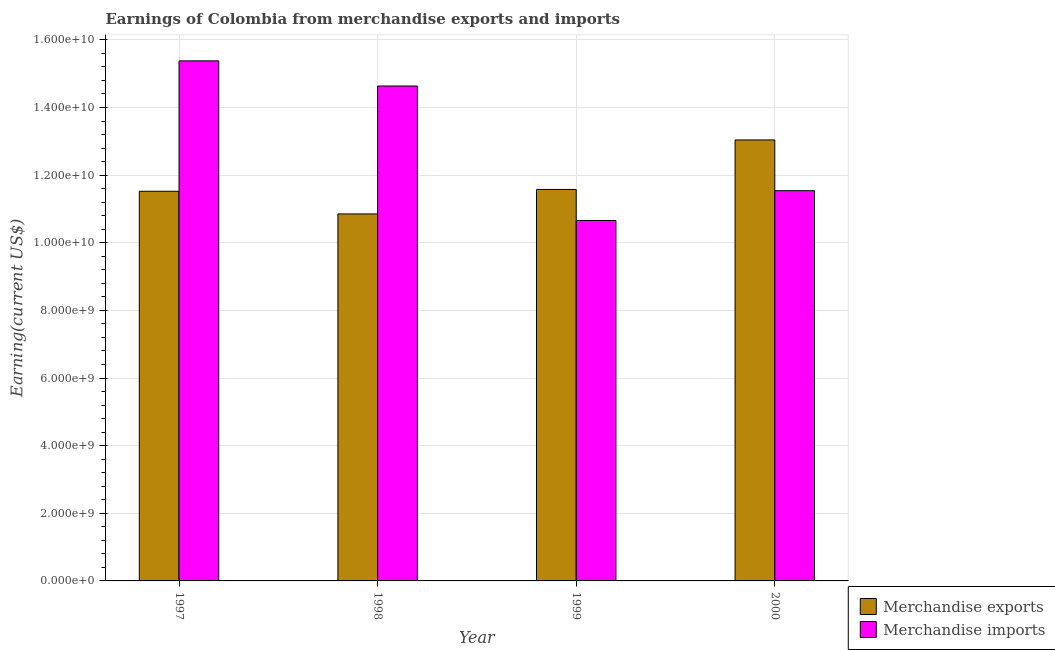Are the number of bars per tick equal to the number of legend labels?
Your response must be concise. Yes. What is the earnings from merchandise exports in 1998?
Ensure brevity in your answer.  1.09e+1. Across all years, what is the maximum earnings from merchandise exports?
Offer a terse response. 1.30e+1. Across all years, what is the minimum earnings from merchandise imports?
Provide a succinct answer. 1.07e+1. In which year was the earnings from merchandise exports maximum?
Offer a very short reply. 2000. In which year was the earnings from merchandise imports minimum?
Give a very brief answer. 1999. What is the total earnings from merchandise imports in the graph?
Your response must be concise. 5.22e+1. What is the difference between the earnings from merchandise imports in 1999 and that in 2000?
Your answer should be compact. -8.80e+08. What is the difference between the earnings from merchandise exports in 2000 and the earnings from merchandise imports in 1997?
Ensure brevity in your answer.  1.52e+09. What is the average earnings from merchandise exports per year?
Provide a succinct answer. 1.17e+1. In how many years, is the earnings from merchandise imports greater than 5200000000 US$?
Your answer should be very brief. 4. What is the ratio of the earnings from merchandise exports in 1997 to that in 1998?
Provide a short and direct response. 1.06. Is the earnings from merchandise imports in 1997 less than that in 1999?
Make the answer very short. No. What is the difference between the highest and the second highest earnings from merchandise exports?
Your answer should be very brief. 1.46e+09. What is the difference between the highest and the lowest earnings from merchandise exports?
Provide a short and direct response. 2.19e+09. What does the 2nd bar from the left in 1999 represents?
Offer a very short reply. Merchandise imports. Are all the bars in the graph horizontal?
Offer a very short reply. No. What is the difference between two consecutive major ticks on the Y-axis?
Provide a succinct answer. 2.00e+09. Are the values on the major ticks of Y-axis written in scientific E-notation?
Offer a terse response. Yes. Where does the legend appear in the graph?
Your answer should be compact. Bottom right. How are the legend labels stacked?
Provide a short and direct response. Vertical. What is the title of the graph?
Give a very brief answer. Earnings of Colombia from merchandise exports and imports. Does "Techinal cooperation" appear as one of the legend labels in the graph?
Your answer should be compact. No. What is the label or title of the Y-axis?
Your answer should be very brief. Earning(current US$). What is the Earning(current US$) in Merchandise exports in 1997?
Your response must be concise. 1.15e+1. What is the Earning(current US$) in Merchandise imports in 1997?
Offer a very short reply. 1.54e+1. What is the Earning(current US$) in Merchandise exports in 1998?
Offer a very short reply. 1.09e+1. What is the Earning(current US$) in Merchandise imports in 1998?
Your response must be concise. 1.46e+1. What is the Earning(current US$) of Merchandise exports in 1999?
Keep it short and to the point. 1.16e+1. What is the Earning(current US$) in Merchandise imports in 1999?
Give a very brief answer. 1.07e+1. What is the Earning(current US$) of Merchandise exports in 2000?
Offer a very short reply. 1.30e+1. What is the Earning(current US$) of Merchandise imports in 2000?
Keep it short and to the point. 1.15e+1. Across all years, what is the maximum Earning(current US$) in Merchandise exports?
Keep it short and to the point. 1.30e+1. Across all years, what is the maximum Earning(current US$) in Merchandise imports?
Offer a terse response. 1.54e+1. Across all years, what is the minimum Earning(current US$) of Merchandise exports?
Your answer should be compact. 1.09e+1. Across all years, what is the minimum Earning(current US$) of Merchandise imports?
Your answer should be compact. 1.07e+1. What is the total Earning(current US$) of Merchandise exports in the graph?
Ensure brevity in your answer.  4.70e+1. What is the total Earning(current US$) in Merchandise imports in the graph?
Ensure brevity in your answer.  5.22e+1. What is the difference between the Earning(current US$) in Merchandise exports in 1997 and that in 1998?
Offer a very short reply. 6.70e+08. What is the difference between the Earning(current US$) of Merchandise imports in 1997 and that in 1998?
Your answer should be compact. 7.43e+08. What is the difference between the Earning(current US$) in Merchandise exports in 1997 and that in 1999?
Offer a very short reply. -5.40e+07. What is the difference between the Earning(current US$) in Merchandise imports in 1997 and that in 1999?
Provide a short and direct response. 4.72e+09. What is the difference between the Earning(current US$) in Merchandise exports in 1997 and that in 2000?
Provide a short and direct response. -1.52e+09. What is the difference between the Earning(current US$) of Merchandise imports in 1997 and that in 2000?
Provide a short and direct response. 3.84e+09. What is the difference between the Earning(current US$) of Merchandise exports in 1998 and that in 1999?
Provide a short and direct response. -7.24e+08. What is the difference between the Earning(current US$) in Merchandise imports in 1998 and that in 1999?
Give a very brief answer. 3.98e+09. What is the difference between the Earning(current US$) in Merchandise exports in 1998 and that in 2000?
Your answer should be very brief. -2.19e+09. What is the difference between the Earning(current US$) of Merchandise imports in 1998 and that in 2000?
Make the answer very short. 3.10e+09. What is the difference between the Earning(current US$) in Merchandise exports in 1999 and that in 2000?
Your answer should be very brief. -1.46e+09. What is the difference between the Earning(current US$) in Merchandise imports in 1999 and that in 2000?
Offer a very short reply. -8.80e+08. What is the difference between the Earning(current US$) of Merchandise exports in 1997 and the Earning(current US$) of Merchandise imports in 1998?
Ensure brevity in your answer.  -3.11e+09. What is the difference between the Earning(current US$) of Merchandise exports in 1997 and the Earning(current US$) of Merchandise imports in 1999?
Provide a succinct answer. 8.63e+08. What is the difference between the Earning(current US$) in Merchandise exports in 1997 and the Earning(current US$) in Merchandise imports in 2000?
Your answer should be very brief. -1.70e+07. What is the difference between the Earning(current US$) of Merchandise exports in 1998 and the Earning(current US$) of Merchandise imports in 1999?
Provide a short and direct response. 1.93e+08. What is the difference between the Earning(current US$) of Merchandise exports in 1998 and the Earning(current US$) of Merchandise imports in 2000?
Provide a succinct answer. -6.87e+08. What is the difference between the Earning(current US$) of Merchandise exports in 1999 and the Earning(current US$) of Merchandise imports in 2000?
Provide a succinct answer. 3.70e+07. What is the average Earning(current US$) of Merchandise exports per year?
Provide a short and direct response. 1.17e+1. What is the average Earning(current US$) in Merchandise imports per year?
Provide a short and direct response. 1.31e+1. In the year 1997, what is the difference between the Earning(current US$) of Merchandise exports and Earning(current US$) of Merchandise imports?
Your answer should be very brief. -3.86e+09. In the year 1998, what is the difference between the Earning(current US$) in Merchandise exports and Earning(current US$) in Merchandise imports?
Give a very brief answer. -3.78e+09. In the year 1999, what is the difference between the Earning(current US$) of Merchandise exports and Earning(current US$) of Merchandise imports?
Provide a short and direct response. 9.17e+08. In the year 2000, what is the difference between the Earning(current US$) of Merchandise exports and Earning(current US$) of Merchandise imports?
Offer a very short reply. 1.50e+09. What is the ratio of the Earning(current US$) of Merchandise exports in 1997 to that in 1998?
Your answer should be very brief. 1.06. What is the ratio of the Earning(current US$) of Merchandise imports in 1997 to that in 1998?
Offer a terse response. 1.05. What is the ratio of the Earning(current US$) in Merchandise exports in 1997 to that in 1999?
Give a very brief answer. 1. What is the ratio of the Earning(current US$) in Merchandise imports in 1997 to that in 1999?
Provide a succinct answer. 1.44. What is the ratio of the Earning(current US$) of Merchandise exports in 1997 to that in 2000?
Your answer should be compact. 0.88. What is the ratio of the Earning(current US$) of Merchandise imports in 1997 to that in 2000?
Your answer should be very brief. 1.33. What is the ratio of the Earning(current US$) of Merchandise exports in 1998 to that in 1999?
Your response must be concise. 0.94. What is the ratio of the Earning(current US$) of Merchandise imports in 1998 to that in 1999?
Give a very brief answer. 1.37. What is the ratio of the Earning(current US$) of Merchandise exports in 1998 to that in 2000?
Provide a succinct answer. 0.83. What is the ratio of the Earning(current US$) of Merchandise imports in 1998 to that in 2000?
Provide a succinct answer. 1.27. What is the ratio of the Earning(current US$) in Merchandise exports in 1999 to that in 2000?
Provide a succinct answer. 0.89. What is the ratio of the Earning(current US$) in Merchandise imports in 1999 to that in 2000?
Ensure brevity in your answer.  0.92. What is the difference between the highest and the second highest Earning(current US$) in Merchandise exports?
Give a very brief answer. 1.46e+09. What is the difference between the highest and the second highest Earning(current US$) of Merchandise imports?
Keep it short and to the point. 7.43e+08. What is the difference between the highest and the lowest Earning(current US$) in Merchandise exports?
Your response must be concise. 2.19e+09. What is the difference between the highest and the lowest Earning(current US$) of Merchandise imports?
Your response must be concise. 4.72e+09. 